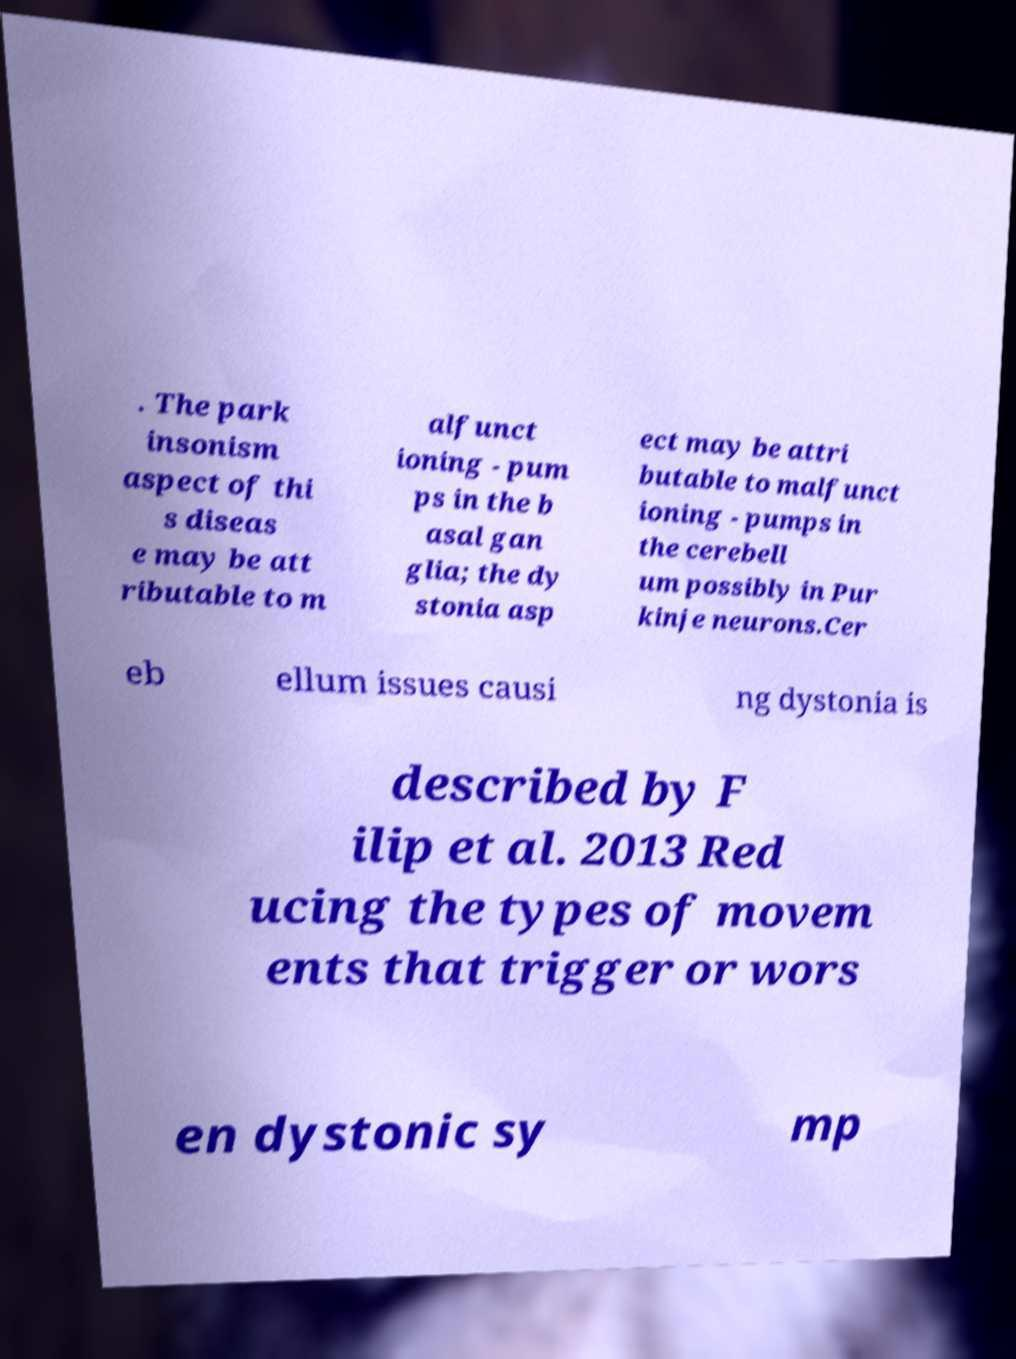Can you read and provide the text displayed in the image?This photo seems to have some interesting text. Can you extract and type it out for me? . The park insonism aspect of thi s diseas e may be att ributable to m alfunct ioning - pum ps in the b asal gan glia; the dy stonia asp ect may be attri butable to malfunct ioning - pumps in the cerebell um possibly in Pur kinje neurons.Cer eb ellum issues causi ng dystonia is described by F ilip et al. 2013 Red ucing the types of movem ents that trigger or wors en dystonic sy mp 